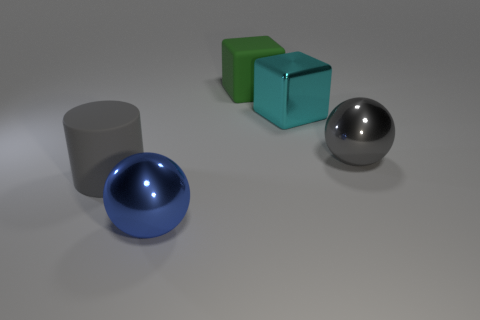Add 3 blue balls. How many objects exist? 8 Subtract all cylinders. How many objects are left? 4 Subtract all green shiny balls. Subtract all cyan cubes. How many objects are left? 4 Add 3 gray rubber things. How many gray rubber things are left? 4 Add 1 small brown metallic cubes. How many small brown metallic cubes exist? 1 Subtract 0 purple cylinders. How many objects are left? 5 